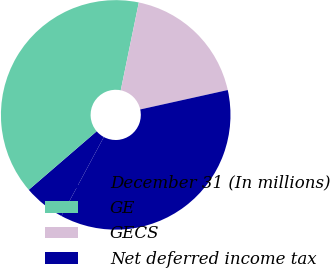<chart> <loc_0><loc_0><loc_500><loc_500><pie_chart><fcel>December 31 (In millions)<fcel>GE<fcel>GECS<fcel>Net deferred income tax<nl><fcel>5.84%<fcel>39.55%<fcel>18.3%<fcel>36.32%<nl></chart> 